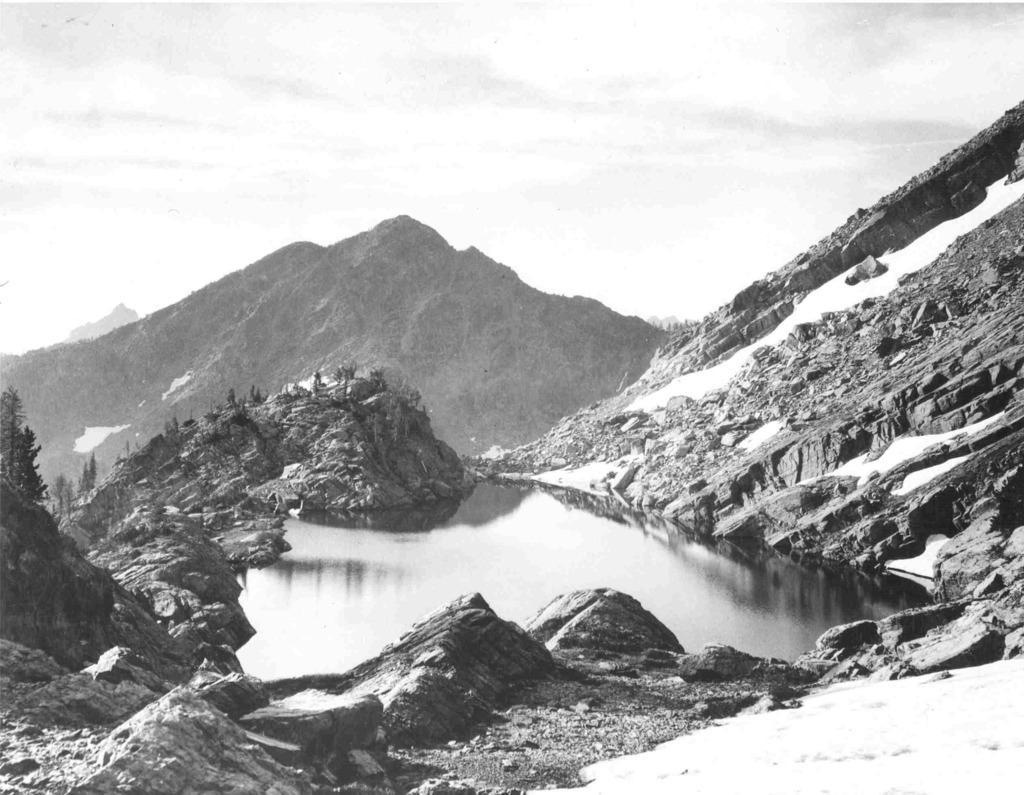Please provide a concise description of this image. In the image we can see two hills. On the top we can see sky and water on the ground. 